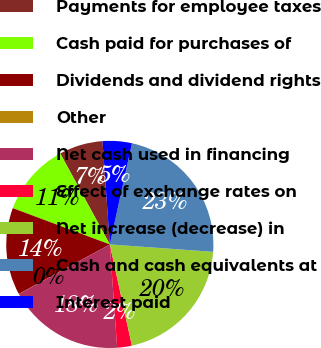<chart> <loc_0><loc_0><loc_500><loc_500><pie_chart><fcel>Payments for employee taxes<fcel>Cash paid for purchases of<fcel>Dividends and dividend rights<fcel>Other<fcel>Net cash used in financing<fcel>Effect of exchange rates on<fcel>Net increase (decrease) in<fcel>Cash and cash equivalents at<fcel>Interest paid<nl><fcel>6.82%<fcel>11.36%<fcel>13.63%<fcel>0.02%<fcel>18.17%<fcel>2.29%<fcel>20.44%<fcel>22.71%<fcel>4.55%<nl></chart> 